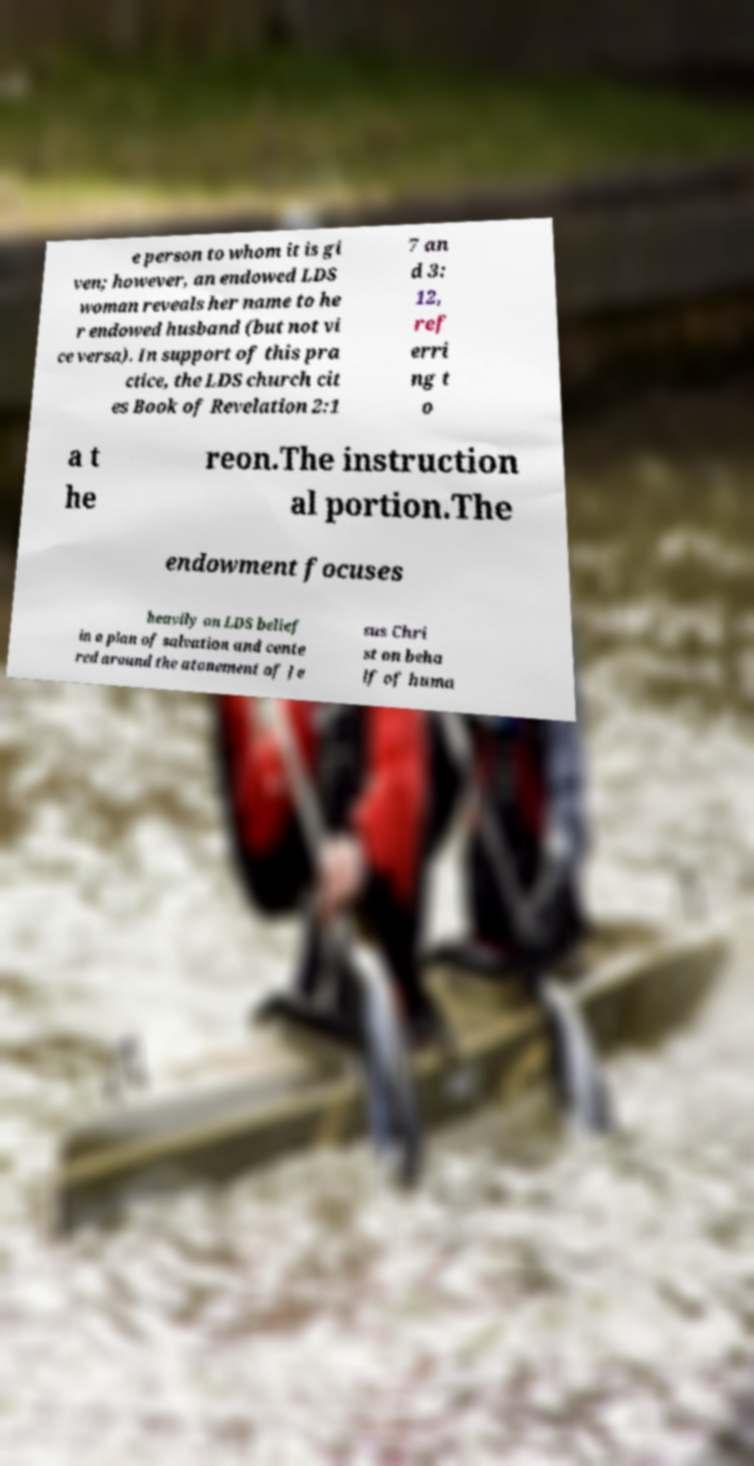Could you extract and type out the text from this image? e person to whom it is gi ven; however, an endowed LDS woman reveals her name to he r endowed husband (but not vi ce versa). In support of this pra ctice, the LDS church cit es Book of Revelation 2:1 7 an d 3: 12, ref erri ng t o a t he reon.The instruction al portion.The endowment focuses heavily on LDS belief in a plan of salvation and cente red around the atonement of Je sus Chri st on beha lf of huma 